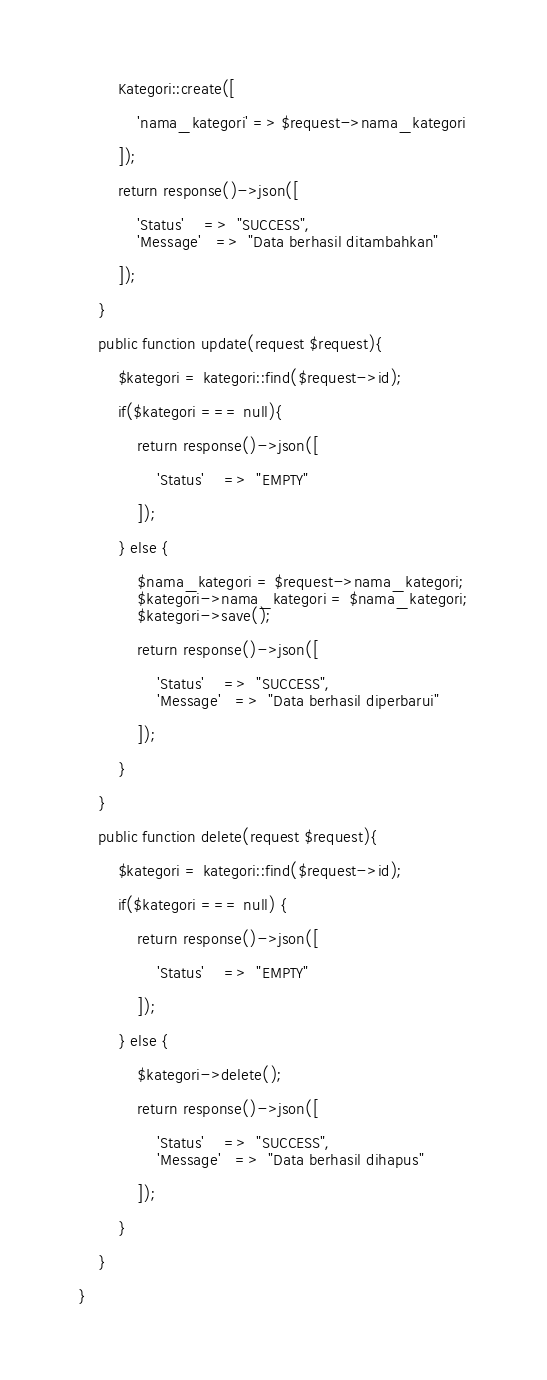Convert code to text. <code><loc_0><loc_0><loc_500><loc_500><_PHP_>		Kategori::create([

			'nama_kategori' => $request->nama_kategori

		]);

		return response()->json([

			'Status'	=>	"SUCCESS",
			'Message'	=>	"Data berhasil ditambahkan"
			
		]);

	}

	public function update(request $request){

		$kategori = kategori::find($request->id);

		if($kategori === null){

			return response()->json([

				'Status'	=>	"EMPTY"
				
			]);

		} else {

			$nama_kategori = $request->nama_kategori;
			$kategori->nama_kategori = $nama_kategori;
			$kategori->save();

			return response()->json([

				'Status'	=>	"SUCCESS",
				'Message'	=>	"Data berhasil diperbarui"
				
			]);

		}

	}

	public function delete(request $request){

		$kategori = kategori::find($request->id);
		
		if($kategori === null) {

			return response()->json([

				'Status'	=>	"EMPTY"
				
			]);

		} else {

			$kategori->delete();

			return response()->json([

				'Status'	=>	"SUCCESS",
				'Message'	=>	"Data berhasil dihapus"
				
			]);

		}

	}

}
</code> 